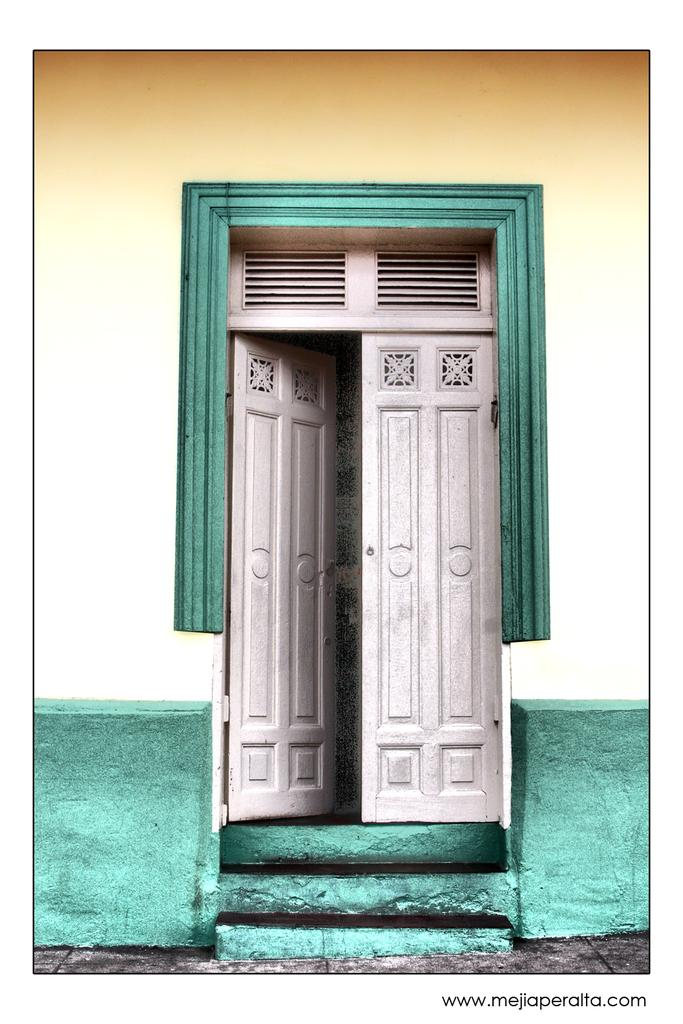What type of structure is visible in the image? There is a wall in the image. Are there any openings in the wall? Yes, there are doors in the image. What architectural feature can be seen in the image? There are stairs in the image. What type of picture is hanging on the wall in the image? There is no picture hanging on the wall in the image; only the wall, doors, and stairs are present. What scene can be seen taking place in the image? There is no scene taking place in the image; it is a static representation of a wall, doors, and stairs. 